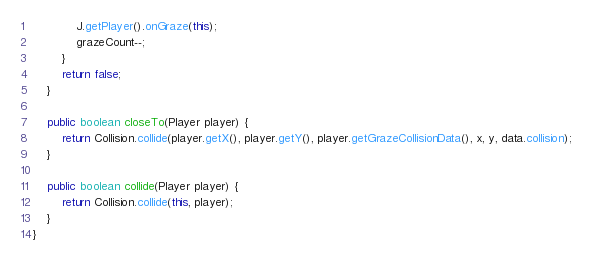<code> <loc_0><loc_0><loc_500><loc_500><_Java_>            J.getPlayer().onGraze(this);
            grazeCount--;
        }
        return false;
    }

    public boolean closeTo(Player player) {
        return Collision.collide(player.getX(), player.getY(), player.getGrazeCollisionData(), x, y, data.collision);
    }

    public boolean collide(Player player) {
        return Collision.collide(this, player);
    }
}
</code> 